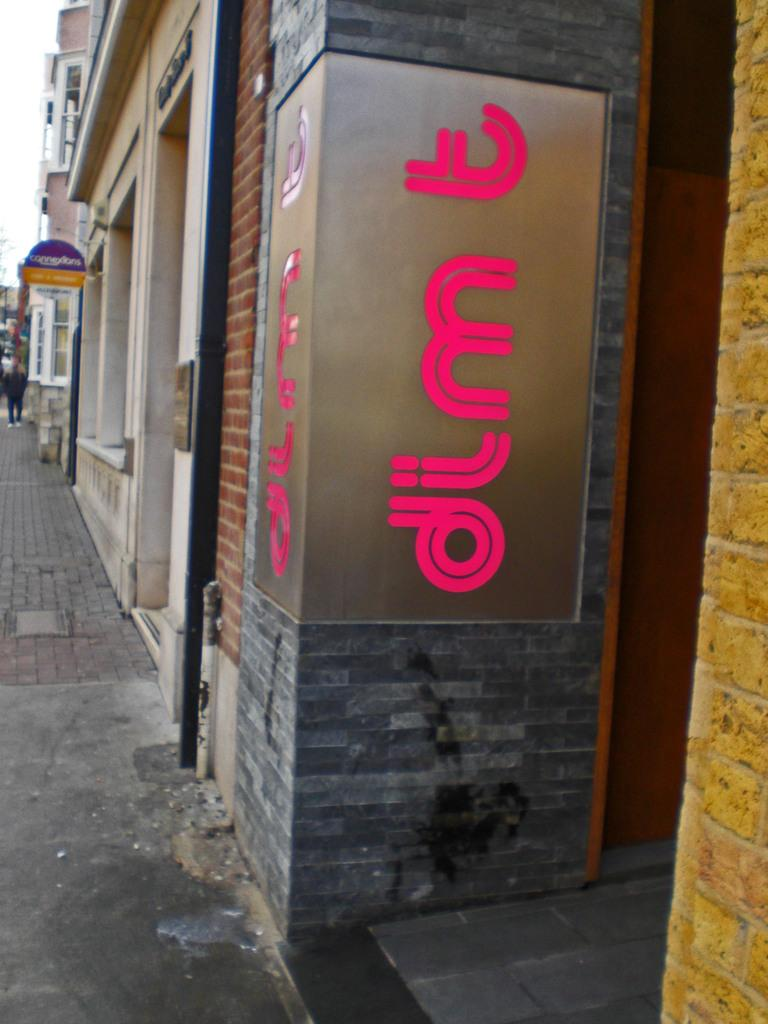What can be seen in the image? There are many shops in the image. What is located at the front of the image? There is located at the front of the image? What type of ground surface is visible in the image? There are cobbler stones on the ground in the image. What type of office can be seen in the image? There is no office present in the image; it features many shops and an advertising board. What is the recess like in the image? There is no recess present in the image; it features many shops, an advertising board, and cobbler stones on the ground. 